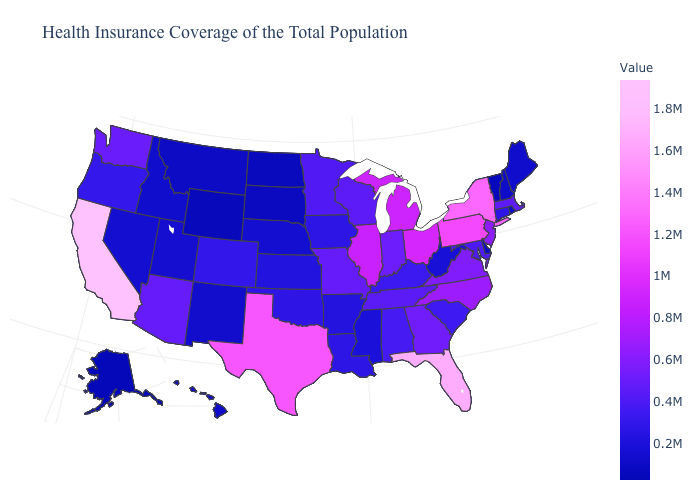Which states have the lowest value in the USA?
Quick response, please. Alaska. Does Florida have the highest value in the South?
Be succinct. Yes. Which states have the lowest value in the MidWest?
Concise answer only. North Dakota. Among the states that border Washington , which have the highest value?
Concise answer only. Oregon. Which states hav the highest value in the West?
Quick response, please. California. Does the map have missing data?
Give a very brief answer. No. Does Hawaii have the lowest value in the USA?
Quick response, please. No. Among the states that border Maryland , which have the lowest value?
Short answer required. Delaware. 